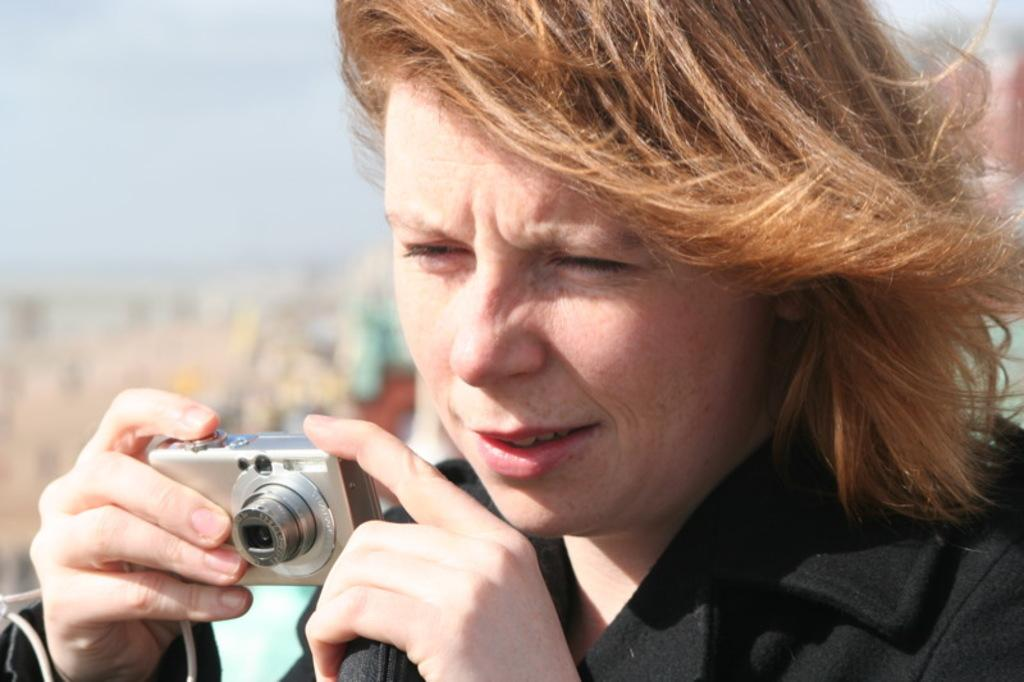Who is the main subject in the image? There is a woman in the image. What is the woman holding in her hand? The woman is holding a camera in her hand. What type of notebook is the woman using to take notes in the image? There is no notebook present in the image; the woman is holding a camera. 